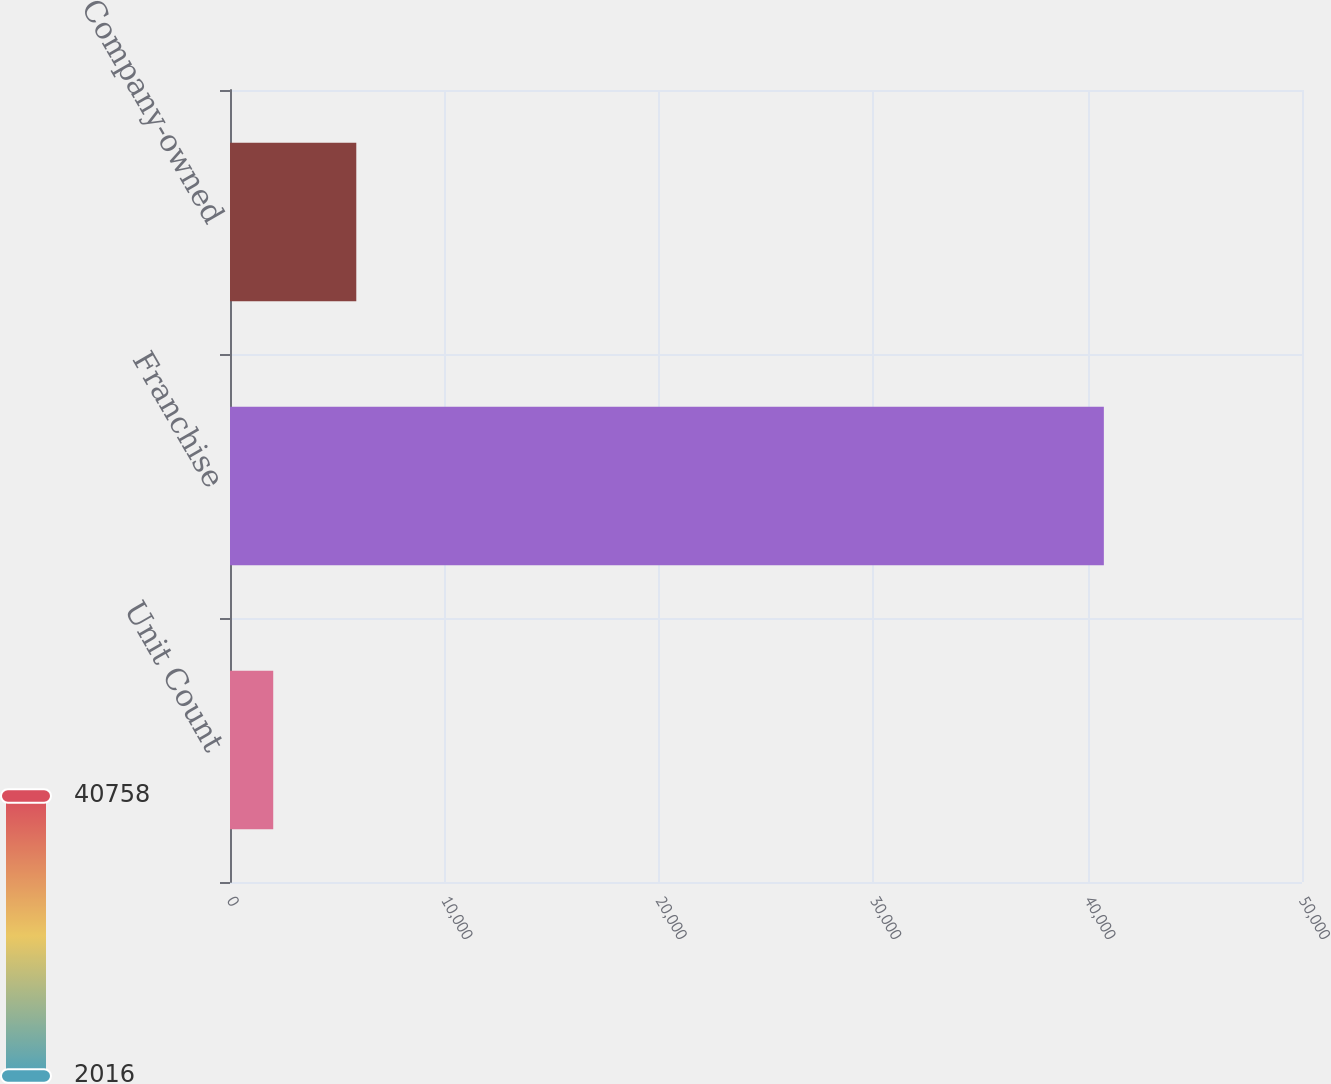<chart> <loc_0><loc_0><loc_500><loc_500><bar_chart><fcel>Unit Count<fcel>Franchise<fcel>Company-owned<nl><fcel>2016<fcel>40758<fcel>5890.2<nl></chart> 